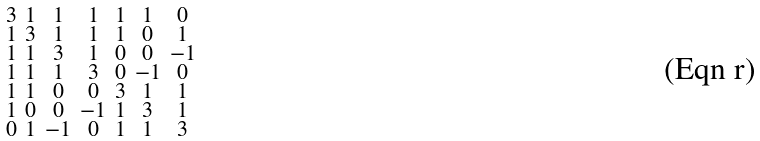<formula> <loc_0><loc_0><loc_500><loc_500>\begin{smallmatrix} 3 & 1 & 1 & 1 & 1 & 1 & 0 \\ 1 & 3 & 1 & 1 & 1 & 0 & 1 \\ 1 & 1 & 3 & 1 & 0 & 0 & - 1 \\ 1 & 1 & 1 & 3 & 0 & - 1 & 0 \\ 1 & 1 & 0 & 0 & 3 & 1 & 1 \\ 1 & 0 & 0 & - 1 & 1 & 3 & 1 \\ 0 & 1 & - 1 & 0 & 1 & 1 & 3 \end{smallmatrix}</formula> 